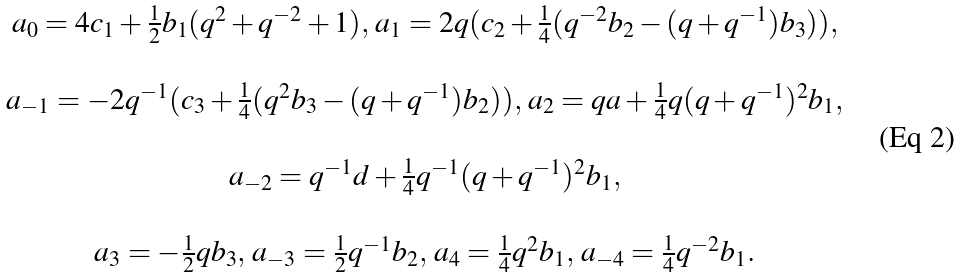<formula> <loc_0><loc_0><loc_500><loc_500>\begin{array} { c } a _ { 0 } = 4 c _ { 1 } + \frac { 1 } { 2 } b _ { 1 } ( q ^ { 2 } + q ^ { - 2 } + 1 ) , \, a _ { 1 } = 2 q ( c _ { 2 } + \frac { 1 } { 4 } ( q ^ { - 2 } b _ { 2 } - ( q + q ^ { - 1 } ) b _ { 3 } ) ) , \\ \\ a _ { - 1 } = - 2 q ^ { - 1 } ( c _ { 3 } + \frac { 1 } { 4 } ( q ^ { 2 } b _ { 3 } - ( q + q ^ { - 1 } ) b _ { 2 } ) ) , \, a _ { 2 } = q a + \frac { 1 } { 4 } q ( q + q ^ { - 1 } ) ^ { 2 } b _ { 1 } , \\ \\ a _ { - 2 } = q ^ { - 1 } d + \frac { 1 } { 4 } q ^ { - 1 } ( q + q ^ { - 1 } ) ^ { 2 } b _ { 1 } , \\ \\ a _ { 3 } = - \frac { 1 } { 2 } q b _ { 3 } , \, a _ { - 3 } = \frac { 1 } { 2 } q ^ { - 1 } b _ { 2 } , \, a _ { 4 } = \frac { 1 } { 4 } q ^ { 2 } b _ { 1 } , \, a _ { - 4 } = \frac { 1 } { 4 } q ^ { - 2 } b _ { 1 } . \end{array}</formula> 